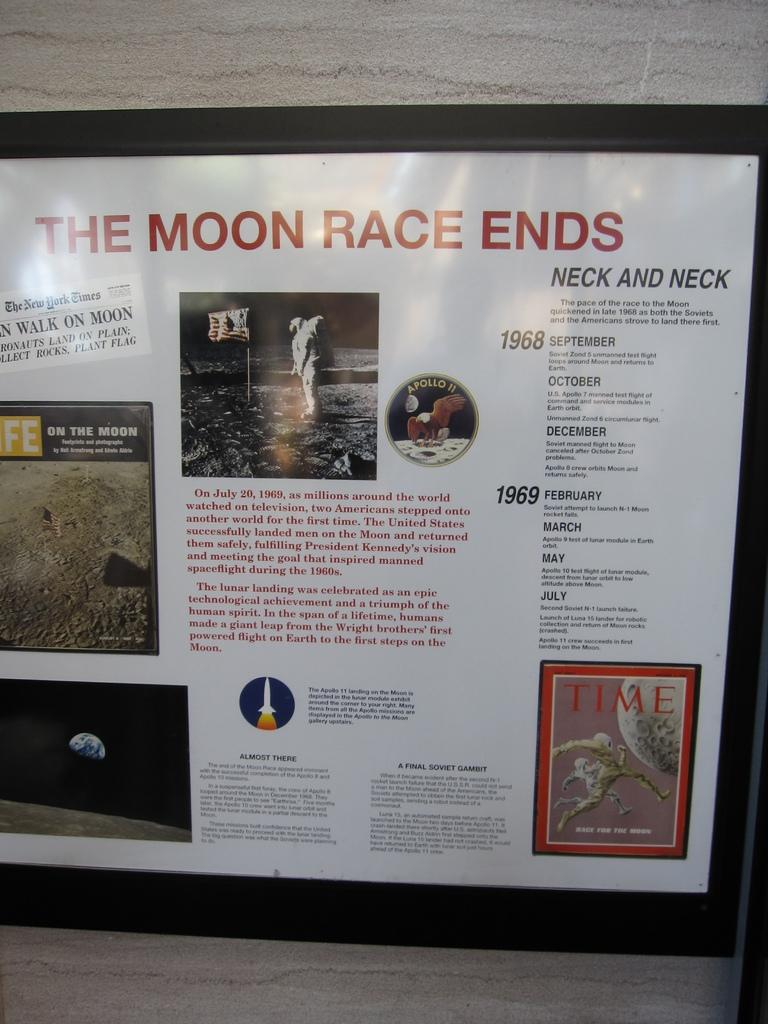<image>
Summarize the visual content of the image. Framed poster for The Moon Race and the years 1968 and 1969 on it. 